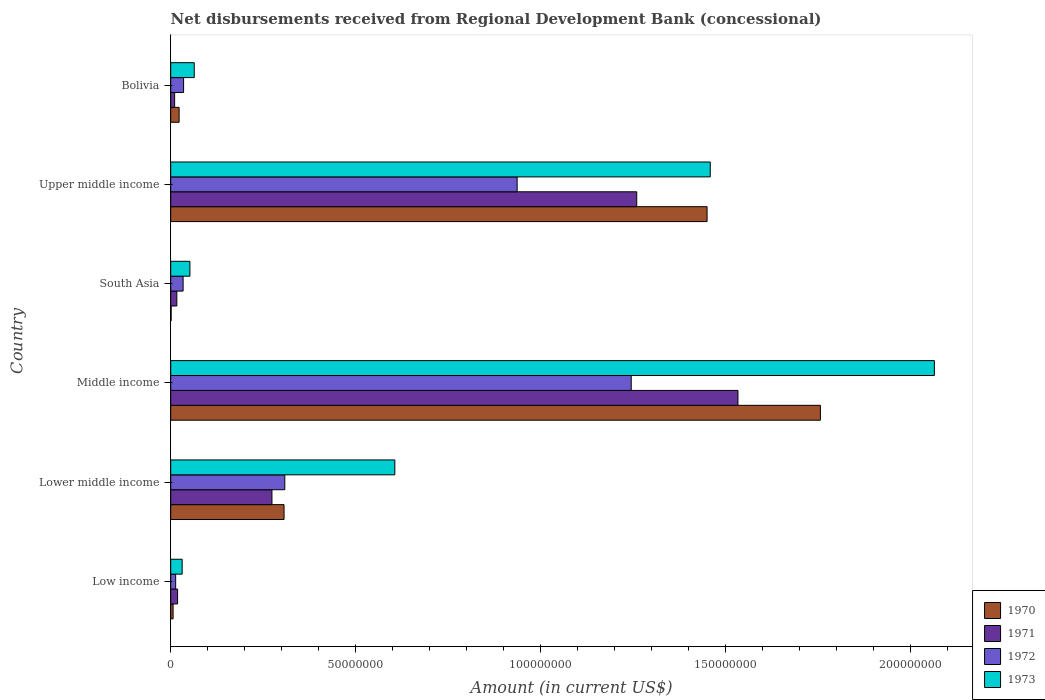How many groups of bars are there?
Provide a succinct answer. 6. How many bars are there on the 6th tick from the top?
Provide a succinct answer. 4. In how many cases, is the number of bars for a given country not equal to the number of legend labels?
Keep it short and to the point. 0. What is the amount of disbursements received from Regional Development Bank in 1970 in Lower middle income?
Your response must be concise. 3.06e+07. Across all countries, what is the maximum amount of disbursements received from Regional Development Bank in 1971?
Provide a short and direct response. 1.53e+08. Across all countries, what is the minimum amount of disbursements received from Regional Development Bank in 1973?
Give a very brief answer. 3.09e+06. In which country was the amount of disbursements received from Regional Development Bank in 1970 minimum?
Make the answer very short. South Asia. What is the total amount of disbursements received from Regional Development Bank in 1973 in the graph?
Provide a succinct answer. 4.27e+08. What is the difference between the amount of disbursements received from Regional Development Bank in 1972 in Low income and that in South Asia?
Make the answer very short. -2.02e+06. What is the difference between the amount of disbursements received from Regional Development Bank in 1972 in Bolivia and the amount of disbursements received from Regional Development Bank in 1970 in Middle income?
Give a very brief answer. -1.72e+08. What is the average amount of disbursements received from Regional Development Bank in 1971 per country?
Provide a succinct answer. 5.19e+07. What is the difference between the amount of disbursements received from Regional Development Bank in 1971 and amount of disbursements received from Regional Development Bank in 1972 in Low income?
Provide a short and direct response. 5.26e+05. What is the ratio of the amount of disbursements received from Regional Development Bank in 1970 in Low income to that in South Asia?
Provide a succinct answer. 5.94. Is the amount of disbursements received from Regional Development Bank in 1971 in Bolivia less than that in Upper middle income?
Your answer should be very brief. Yes. Is the difference between the amount of disbursements received from Regional Development Bank in 1971 in Bolivia and Middle income greater than the difference between the amount of disbursements received from Regional Development Bank in 1972 in Bolivia and Middle income?
Offer a terse response. No. What is the difference between the highest and the second highest amount of disbursements received from Regional Development Bank in 1970?
Offer a very short reply. 3.06e+07. What is the difference between the highest and the lowest amount of disbursements received from Regional Development Bank in 1970?
Your response must be concise. 1.75e+08. In how many countries, is the amount of disbursements received from Regional Development Bank in 1971 greater than the average amount of disbursements received from Regional Development Bank in 1971 taken over all countries?
Offer a very short reply. 2. Is the sum of the amount of disbursements received from Regional Development Bank in 1973 in Bolivia and Low income greater than the maximum amount of disbursements received from Regional Development Bank in 1970 across all countries?
Make the answer very short. No. Is it the case that in every country, the sum of the amount of disbursements received from Regional Development Bank in 1973 and amount of disbursements received from Regional Development Bank in 1972 is greater than the sum of amount of disbursements received from Regional Development Bank in 1971 and amount of disbursements received from Regional Development Bank in 1970?
Offer a terse response. No. What does the 4th bar from the top in South Asia represents?
Offer a terse response. 1970. What does the 1st bar from the bottom in Low income represents?
Your answer should be very brief. 1970. Is it the case that in every country, the sum of the amount of disbursements received from Regional Development Bank in 1970 and amount of disbursements received from Regional Development Bank in 1971 is greater than the amount of disbursements received from Regional Development Bank in 1972?
Your answer should be compact. No. How many bars are there?
Make the answer very short. 24. Are all the bars in the graph horizontal?
Offer a very short reply. Yes. What is the difference between two consecutive major ticks on the X-axis?
Keep it short and to the point. 5.00e+07. Does the graph contain any zero values?
Offer a very short reply. No. Does the graph contain grids?
Keep it short and to the point. No. What is the title of the graph?
Your answer should be compact. Net disbursements received from Regional Development Bank (concessional). Does "1984" appear as one of the legend labels in the graph?
Offer a very short reply. No. What is the label or title of the X-axis?
Provide a short and direct response. Amount (in current US$). What is the Amount (in current US$) of 1970 in Low income?
Keep it short and to the point. 6.47e+05. What is the Amount (in current US$) in 1971 in Low income?
Make the answer very short. 1.86e+06. What is the Amount (in current US$) of 1972 in Low income?
Keep it short and to the point. 1.33e+06. What is the Amount (in current US$) in 1973 in Low income?
Offer a very short reply. 3.09e+06. What is the Amount (in current US$) in 1970 in Lower middle income?
Offer a very short reply. 3.06e+07. What is the Amount (in current US$) in 1971 in Lower middle income?
Offer a terse response. 2.74e+07. What is the Amount (in current US$) of 1972 in Lower middle income?
Provide a succinct answer. 3.08e+07. What is the Amount (in current US$) in 1973 in Lower middle income?
Your response must be concise. 6.06e+07. What is the Amount (in current US$) in 1970 in Middle income?
Offer a very short reply. 1.76e+08. What is the Amount (in current US$) in 1971 in Middle income?
Your response must be concise. 1.53e+08. What is the Amount (in current US$) in 1972 in Middle income?
Your answer should be compact. 1.24e+08. What is the Amount (in current US$) in 1973 in Middle income?
Keep it short and to the point. 2.06e+08. What is the Amount (in current US$) in 1970 in South Asia?
Your answer should be very brief. 1.09e+05. What is the Amount (in current US$) in 1971 in South Asia?
Keep it short and to the point. 1.65e+06. What is the Amount (in current US$) in 1972 in South Asia?
Offer a very short reply. 3.35e+06. What is the Amount (in current US$) in 1973 in South Asia?
Your answer should be compact. 5.18e+06. What is the Amount (in current US$) in 1970 in Upper middle income?
Ensure brevity in your answer.  1.45e+08. What is the Amount (in current US$) of 1971 in Upper middle income?
Make the answer very short. 1.26e+08. What is the Amount (in current US$) in 1972 in Upper middle income?
Give a very brief answer. 9.36e+07. What is the Amount (in current US$) in 1973 in Upper middle income?
Keep it short and to the point. 1.46e+08. What is the Amount (in current US$) in 1970 in Bolivia?
Make the answer very short. 2.27e+06. What is the Amount (in current US$) of 1971 in Bolivia?
Make the answer very short. 1.06e+06. What is the Amount (in current US$) in 1972 in Bolivia?
Your response must be concise. 3.48e+06. What is the Amount (in current US$) of 1973 in Bolivia?
Provide a succinct answer. 6.36e+06. Across all countries, what is the maximum Amount (in current US$) of 1970?
Your response must be concise. 1.76e+08. Across all countries, what is the maximum Amount (in current US$) of 1971?
Your answer should be very brief. 1.53e+08. Across all countries, what is the maximum Amount (in current US$) in 1972?
Your answer should be very brief. 1.24e+08. Across all countries, what is the maximum Amount (in current US$) in 1973?
Keep it short and to the point. 2.06e+08. Across all countries, what is the minimum Amount (in current US$) of 1970?
Offer a terse response. 1.09e+05. Across all countries, what is the minimum Amount (in current US$) of 1971?
Offer a very short reply. 1.06e+06. Across all countries, what is the minimum Amount (in current US$) in 1972?
Provide a short and direct response. 1.33e+06. Across all countries, what is the minimum Amount (in current US$) of 1973?
Your answer should be compact. 3.09e+06. What is the total Amount (in current US$) in 1970 in the graph?
Provide a short and direct response. 3.54e+08. What is the total Amount (in current US$) of 1971 in the graph?
Ensure brevity in your answer.  3.11e+08. What is the total Amount (in current US$) of 1972 in the graph?
Provide a short and direct response. 2.57e+08. What is the total Amount (in current US$) in 1973 in the graph?
Your answer should be very brief. 4.27e+08. What is the difference between the Amount (in current US$) of 1970 in Low income and that in Lower middle income?
Offer a very short reply. -3.00e+07. What is the difference between the Amount (in current US$) of 1971 in Low income and that in Lower middle income?
Offer a terse response. -2.55e+07. What is the difference between the Amount (in current US$) of 1972 in Low income and that in Lower middle income?
Provide a succinct answer. -2.95e+07. What is the difference between the Amount (in current US$) in 1973 in Low income and that in Lower middle income?
Provide a short and direct response. -5.75e+07. What is the difference between the Amount (in current US$) of 1970 in Low income and that in Middle income?
Offer a terse response. -1.75e+08. What is the difference between the Amount (in current US$) of 1971 in Low income and that in Middle income?
Keep it short and to the point. -1.51e+08. What is the difference between the Amount (in current US$) of 1972 in Low income and that in Middle income?
Your response must be concise. -1.23e+08. What is the difference between the Amount (in current US$) of 1973 in Low income and that in Middle income?
Give a very brief answer. -2.03e+08. What is the difference between the Amount (in current US$) in 1970 in Low income and that in South Asia?
Your response must be concise. 5.38e+05. What is the difference between the Amount (in current US$) in 1971 in Low income and that in South Asia?
Your answer should be very brief. 2.09e+05. What is the difference between the Amount (in current US$) in 1972 in Low income and that in South Asia?
Your answer should be compact. -2.02e+06. What is the difference between the Amount (in current US$) of 1973 in Low income and that in South Asia?
Provide a short and direct response. -2.09e+06. What is the difference between the Amount (in current US$) of 1970 in Low income and that in Upper middle income?
Give a very brief answer. -1.44e+08. What is the difference between the Amount (in current US$) in 1971 in Low income and that in Upper middle income?
Provide a short and direct response. -1.24e+08. What is the difference between the Amount (in current US$) of 1972 in Low income and that in Upper middle income?
Offer a terse response. -9.23e+07. What is the difference between the Amount (in current US$) in 1973 in Low income and that in Upper middle income?
Give a very brief answer. -1.43e+08. What is the difference between the Amount (in current US$) in 1970 in Low income and that in Bolivia?
Your answer should be compact. -1.62e+06. What is the difference between the Amount (in current US$) of 1971 in Low income and that in Bolivia?
Your answer should be very brief. 8.01e+05. What is the difference between the Amount (in current US$) of 1972 in Low income and that in Bolivia?
Provide a succinct answer. -2.15e+06. What is the difference between the Amount (in current US$) of 1973 in Low income and that in Bolivia?
Your answer should be compact. -3.27e+06. What is the difference between the Amount (in current US$) in 1970 in Lower middle income and that in Middle income?
Your answer should be compact. -1.45e+08. What is the difference between the Amount (in current US$) of 1971 in Lower middle income and that in Middle income?
Keep it short and to the point. -1.26e+08. What is the difference between the Amount (in current US$) of 1972 in Lower middle income and that in Middle income?
Ensure brevity in your answer.  -9.36e+07. What is the difference between the Amount (in current US$) in 1973 in Lower middle income and that in Middle income?
Your answer should be compact. -1.46e+08. What is the difference between the Amount (in current US$) of 1970 in Lower middle income and that in South Asia?
Offer a very short reply. 3.05e+07. What is the difference between the Amount (in current US$) in 1971 in Lower middle income and that in South Asia?
Give a very brief answer. 2.57e+07. What is the difference between the Amount (in current US$) in 1972 in Lower middle income and that in South Asia?
Your answer should be compact. 2.75e+07. What is the difference between the Amount (in current US$) of 1973 in Lower middle income and that in South Asia?
Offer a very short reply. 5.54e+07. What is the difference between the Amount (in current US$) of 1970 in Lower middle income and that in Upper middle income?
Give a very brief answer. -1.14e+08. What is the difference between the Amount (in current US$) of 1971 in Lower middle income and that in Upper middle income?
Ensure brevity in your answer.  -9.86e+07. What is the difference between the Amount (in current US$) in 1972 in Lower middle income and that in Upper middle income?
Keep it short and to the point. -6.28e+07. What is the difference between the Amount (in current US$) in 1973 in Lower middle income and that in Upper middle income?
Provide a succinct answer. -8.52e+07. What is the difference between the Amount (in current US$) in 1970 in Lower middle income and that in Bolivia?
Ensure brevity in your answer.  2.84e+07. What is the difference between the Amount (in current US$) of 1971 in Lower middle income and that in Bolivia?
Your answer should be very brief. 2.63e+07. What is the difference between the Amount (in current US$) in 1972 in Lower middle income and that in Bolivia?
Provide a succinct answer. 2.73e+07. What is the difference between the Amount (in current US$) in 1973 in Lower middle income and that in Bolivia?
Offer a very short reply. 5.42e+07. What is the difference between the Amount (in current US$) of 1970 in Middle income and that in South Asia?
Give a very brief answer. 1.75e+08. What is the difference between the Amount (in current US$) of 1971 in Middle income and that in South Asia?
Your answer should be compact. 1.52e+08. What is the difference between the Amount (in current US$) of 1972 in Middle income and that in South Asia?
Offer a very short reply. 1.21e+08. What is the difference between the Amount (in current US$) of 1973 in Middle income and that in South Asia?
Your response must be concise. 2.01e+08. What is the difference between the Amount (in current US$) in 1970 in Middle income and that in Upper middle income?
Offer a terse response. 3.06e+07. What is the difference between the Amount (in current US$) in 1971 in Middle income and that in Upper middle income?
Make the answer very short. 2.74e+07. What is the difference between the Amount (in current US$) of 1972 in Middle income and that in Upper middle income?
Your response must be concise. 3.08e+07. What is the difference between the Amount (in current US$) of 1973 in Middle income and that in Upper middle income?
Your response must be concise. 6.06e+07. What is the difference between the Amount (in current US$) in 1970 in Middle income and that in Bolivia?
Your answer should be very brief. 1.73e+08. What is the difference between the Amount (in current US$) in 1971 in Middle income and that in Bolivia?
Make the answer very short. 1.52e+08. What is the difference between the Amount (in current US$) in 1972 in Middle income and that in Bolivia?
Offer a terse response. 1.21e+08. What is the difference between the Amount (in current US$) in 1973 in Middle income and that in Bolivia?
Keep it short and to the point. 2.00e+08. What is the difference between the Amount (in current US$) in 1970 in South Asia and that in Upper middle income?
Offer a terse response. -1.45e+08. What is the difference between the Amount (in current US$) in 1971 in South Asia and that in Upper middle income?
Provide a short and direct response. -1.24e+08. What is the difference between the Amount (in current US$) in 1972 in South Asia and that in Upper middle income?
Make the answer very short. -9.03e+07. What is the difference between the Amount (in current US$) in 1973 in South Asia and that in Upper middle income?
Make the answer very short. -1.41e+08. What is the difference between the Amount (in current US$) of 1970 in South Asia and that in Bolivia?
Make the answer very short. -2.16e+06. What is the difference between the Amount (in current US$) in 1971 in South Asia and that in Bolivia?
Your answer should be compact. 5.92e+05. What is the difference between the Amount (in current US$) in 1972 in South Asia and that in Bolivia?
Make the answer very short. -1.30e+05. What is the difference between the Amount (in current US$) in 1973 in South Asia and that in Bolivia?
Offer a terse response. -1.18e+06. What is the difference between the Amount (in current US$) of 1970 in Upper middle income and that in Bolivia?
Your response must be concise. 1.43e+08. What is the difference between the Amount (in current US$) in 1971 in Upper middle income and that in Bolivia?
Your answer should be very brief. 1.25e+08. What is the difference between the Amount (in current US$) in 1972 in Upper middle income and that in Bolivia?
Keep it short and to the point. 9.01e+07. What is the difference between the Amount (in current US$) in 1973 in Upper middle income and that in Bolivia?
Offer a terse response. 1.39e+08. What is the difference between the Amount (in current US$) in 1970 in Low income and the Amount (in current US$) in 1971 in Lower middle income?
Offer a terse response. -2.67e+07. What is the difference between the Amount (in current US$) in 1970 in Low income and the Amount (in current US$) in 1972 in Lower middle income?
Ensure brevity in your answer.  -3.02e+07. What is the difference between the Amount (in current US$) of 1970 in Low income and the Amount (in current US$) of 1973 in Lower middle income?
Give a very brief answer. -5.99e+07. What is the difference between the Amount (in current US$) in 1971 in Low income and the Amount (in current US$) in 1972 in Lower middle income?
Your answer should be compact. -2.90e+07. What is the difference between the Amount (in current US$) in 1971 in Low income and the Amount (in current US$) in 1973 in Lower middle income?
Your answer should be very brief. -5.87e+07. What is the difference between the Amount (in current US$) in 1972 in Low income and the Amount (in current US$) in 1973 in Lower middle income?
Give a very brief answer. -5.92e+07. What is the difference between the Amount (in current US$) of 1970 in Low income and the Amount (in current US$) of 1971 in Middle income?
Give a very brief answer. -1.53e+08. What is the difference between the Amount (in current US$) in 1970 in Low income and the Amount (in current US$) in 1972 in Middle income?
Give a very brief answer. -1.24e+08. What is the difference between the Amount (in current US$) in 1970 in Low income and the Amount (in current US$) in 1973 in Middle income?
Your answer should be compact. -2.06e+08. What is the difference between the Amount (in current US$) in 1971 in Low income and the Amount (in current US$) in 1972 in Middle income?
Your answer should be compact. -1.23e+08. What is the difference between the Amount (in current US$) in 1971 in Low income and the Amount (in current US$) in 1973 in Middle income?
Provide a succinct answer. -2.04e+08. What is the difference between the Amount (in current US$) in 1972 in Low income and the Amount (in current US$) in 1973 in Middle income?
Ensure brevity in your answer.  -2.05e+08. What is the difference between the Amount (in current US$) of 1970 in Low income and the Amount (in current US$) of 1971 in South Asia?
Provide a short and direct response. -1.00e+06. What is the difference between the Amount (in current US$) in 1970 in Low income and the Amount (in current US$) in 1972 in South Asia?
Keep it short and to the point. -2.70e+06. What is the difference between the Amount (in current US$) in 1970 in Low income and the Amount (in current US$) in 1973 in South Asia?
Your response must be concise. -4.54e+06. What is the difference between the Amount (in current US$) in 1971 in Low income and the Amount (in current US$) in 1972 in South Asia?
Offer a terse response. -1.49e+06. What is the difference between the Amount (in current US$) of 1971 in Low income and the Amount (in current US$) of 1973 in South Asia?
Your answer should be compact. -3.32e+06. What is the difference between the Amount (in current US$) in 1972 in Low income and the Amount (in current US$) in 1973 in South Asia?
Provide a succinct answer. -3.85e+06. What is the difference between the Amount (in current US$) of 1970 in Low income and the Amount (in current US$) of 1971 in Upper middle income?
Keep it short and to the point. -1.25e+08. What is the difference between the Amount (in current US$) of 1970 in Low income and the Amount (in current US$) of 1972 in Upper middle income?
Keep it short and to the point. -9.30e+07. What is the difference between the Amount (in current US$) in 1970 in Low income and the Amount (in current US$) in 1973 in Upper middle income?
Offer a terse response. -1.45e+08. What is the difference between the Amount (in current US$) of 1971 in Low income and the Amount (in current US$) of 1972 in Upper middle income?
Keep it short and to the point. -9.17e+07. What is the difference between the Amount (in current US$) of 1971 in Low income and the Amount (in current US$) of 1973 in Upper middle income?
Keep it short and to the point. -1.44e+08. What is the difference between the Amount (in current US$) in 1972 in Low income and the Amount (in current US$) in 1973 in Upper middle income?
Your answer should be very brief. -1.44e+08. What is the difference between the Amount (in current US$) in 1970 in Low income and the Amount (in current US$) in 1971 in Bolivia?
Offer a terse response. -4.11e+05. What is the difference between the Amount (in current US$) of 1970 in Low income and the Amount (in current US$) of 1972 in Bolivia?
Offer a terse response. -2.83e+06. What is the difference between the Amount (in current US$) in 1970 in Low income and the Amount (in current US$) in 1973 in Bolivia?
Provide a short and direct response. -5.71e+06. What is the difference between the Amount (in current US$) of 1971 in Low income and the Amount (in current US$) of 1972 in Bolivia?
Provide a succinct answer. -1.62e+06. What is the difference between the Amount (in current US$) of 1971 in Low income and the Amount (in current US$) of 1973 in Bolivia?
Your response must be concise. -4.50e+06. What is the difference between the Amount (in current US$) of 1972 in Low income and the Amount (in current US$) of 1973 in Bolivia?
Your response must be concise. -5.03e+06. What is the difference between the Amount (in current US$) in 1970 in Lower middle income and the Amount (in current US$) in 1971 in Middle income?
Offer a very short reply. -1.23e+08. What is the difference between the Amount (in current US$) of 1970 in Lower middle income and the Amount (in current US$) of 1972 in Middle income?
Your answer should be very brief. -9.38e+07. What is the difference between the Amount (in current US$) of 1970 in Lower middle income and the Amount (in current US$) of 1973 in Middle income?
Give a very brief answer. -1.76e+08. What is the difference between the Amount (in current US$) of 1971 in Lower middle income and the Amount (in current US$) of 1972 in Middle income?
Offer a terse response. -9.71e+07. What is the difference between the Amount (in current US$) in 1971 in Lower middle income and the Amount (in current US$) in 1973 in Middle income?
Provide a succinct answer. -1.79e+08. What is the difference between the Amount (in current US$) in 1972 in Lower middle income and the Amount (in current US$) in 1973 in Middle income?
Make the answer very short. -1.76e+08. What is the difference between the Amount (in current US$) of 1970 in Lower middle income and the Amount (in current US$) of 1971 in South Asia?
Offer a terse response. 2.90e+07. What is the difference between the Amount (in current US$) of 1970 in Lower middle income and the Amount (in current US$) of 1972 in South Asia?
Offer a terse response. 2.73e+07. What is the difference between the Amount (in current US$) of 1970 in Lower middle income and the Amount (in current US$) of 1973 in South Asia?
Make the answer very short. 2.54e+07. What is the difference between the Amount (in current US$) of 1971 in Lower middle income and the Amount (in current US$) of 1972 in South Asia?
Keep it short and to the point. 2.40e+07. What is the difference between the Amount (in current US$) of 1971 in Lower middle income and the Amount (in current US$) of 1973 in South Asia?
Make the answer very short. 2.22e+07. What is the difference between the Amount (in current US$) in 1972 in Lower middle income and the Amount (in current US$) in 1973 in South Asia?
Give a very brief answer. 2.56e+07. What is the difference between the Amount (in current US$) in 1970 in Lower middle income and the Amount (in current US$) in 1971 in Upper middle income?
Give a very brief answer. -9.53e+07. What is the difference between the Amount (in current US$) of 1970 in Lower middle income and the Amount (in current US$) of 1972 in Upper middle income?
Give a very brief answer. -6.30e+07. What is the difference between the Amount (in current US$) in 1970 in Lower middle income and the Amount (in current US$) in 1973 in Upper middle income?
Your response must be concise. -1.15e+08. What is the difference between the Amount (in current US$) in 1971 in Lower middle income and the Amount (in current US$) in 1972 in Upper middle income?
Make the answer very short. -6.63e+07. What is the difference between the Amount (in current US$) of 1971 in Lower middle income and the Amount (in current US$) of 1973 in Upper middle income?
Provide a short and direct response. -1.18e+08. What is the difference between the Amount (in current US$) in 1972 in Lower middle income and the Amount (in current US$) in 1973 in Upper middle income?
Your answer should be compact. -1.15e+08. What is the difference between the Amount (in current US$) in 1970 in Lower middle income and the Amount (in current US$) in 1971 in Bolivia?
Provide a short and direct response. 2.96e+07. What is the difference between the Amount (in current US$) in 1970 in Lower middle income and the Amount (in current US$) in 1972 in Bolivia?
Make the answer very short. 2.71e+07. What is the difference between the Amount (in current US$) in 1970 in Lower middle income and the Amount (in current US$) in 1973 in Bolivia?
Keep it short and to the point. 2.43e+07. What is the difference between the Amount (in current US$) of 1971 in Lower middle income and the Amount (in current US$) of 1972 in Bolivia?
Make the answer very short. 2.39e+07. What is the difference between the Amount (in current US$) in 1971 in Lower middle income and the Amount (in current US$) in 1973 in Bolivia?
Your response must be concise. 2.10e+07. What is the difference between the Amount (in current US$) in 1972 in Lower middle income and the Amount (in current US$) in 1973 in Bolivia?
Your response must be concise. 2.45e+07. What is the difference between the Amount (in current US$) of 1970 in Middle income and the Amount (in current US$) of 1971 in South Asia?
Provide a succinct answer. 1.74e+08. What is the difference between the Amount (in current US$) in 1970 in Middle income and the Amount (in current US$) in 1972 in South Asia?
Your answer should be compact. 1.72e+08. What is the difference between the Amount (in current US$) of 1970 in Middle income and the Amount (in current US$) of 1973 in South Asia?
Keep it short and to the point. 1.70e+08. What is the difference between the Amount (in current US$) in 1971 in Middle income and the Amount (in current US$) in 1972 in South Asia?
Your answer should be very brief. 1.50e+08. What is the difference between the Amount (in current US$) of 1971 in Middle income and the Amount (in current US$) of 1973 in South Asia?
Provide a short and direct response. 1.48e+08. What is the difference between the Amount (in current US$) of 1972 in Middle income and the Amount (in current US$) of 1973 in South Asia?
Offer a very short reply. 1.19e+08. What is the difference between the Amount (in current US$) of 1970 in Middle income and the Amount (in current US$) of 1971 in Upper middle income?
Your answer should be very brief. 4.96e+07. What is the difference between the Amount (in current US$) of 1970 in Middle income and the Amount (in current US$) of 1972 in Upper middle income?
Your response must be concise. 8.19e+07. What is the difference between the Amount (in current US$) in 1970 in Middle income and the Amount (in current US$) in 1973 in Upper middle income?
Provide a succinct answer. 2.98e+07. What is the difference between the Amount (in current US$) in 1971 in Middle income and the Amount (in current US$) in 1972 in Upper middle income?
Your answer should be very brief. 5.97e+07. What is the difference between the Amount (in current US$) in 1971 in Middle income and the Amount (in current US$) in 1973 in Upper middle income?
Ensure brevity in your answer.  7.49e+06. What is the difference between the Amount (in current US$) in 1972 in Middle income and the Amount (in current US$) in 1973 in Upper middle income?
Your answer should be compact. -2.14e+07. What is the difference between the Amount (in current US$) of 1970 in Middle income and the Amount (in current US$) of 1971 in Bolivia?
Ensure brevity in your answer.  1.74e+08. What is the difference between the Amount (in current US$) of 1970 in Middle income and the Amount (in current US$) of 1972 in Bolivia?
Offer a terse response. 1.72e+08. What is the difference between the Amount (in current US$) in 1970 in Middle income and the Amount (in current US$) in 1973 in Bolivia?
Ensure brevity in your answer.  1.69e+08. What is the difference between the Amount (in current US$) of 1971 in Middle income and the Amount (in current US$) of 1972 in Bolivia?
Your response must be concise. 1.50e+08. What is the difference between the Amount (in current US$) of 1971 in Middle income and the Amount (in current US$) of 1973 in Bolivia?
Ensure brevity in your answer.  1.47e+08. What is the difference between the Amount (in current US$) of 1972 in Middle income and the Amount (in current US$) of 1973 in Bolivia?
Your answer should be very brief. 1.18e+08. What is the difference between the Amount (in current US$) in 1970 in South Asia and the Amount (in current US$) in 1971 in Upper middle income?
Give a very brief answer. -1.26e+08. What is the difference between the Amount (in current US$) in 1970 in South Asia and the Amount (in current US$) in 1972 in Upper middle income?
Ensure brevity in your answer.  -9.35e+07. What is the difference between the Amount (in current US$) in 1970 in South Asia and the Amount (in current US$) in 1973 in Upper middle income?
Give a very brief answer. -1.46e+08. What is the difference between the Amount (in current US$) of 1971 in South Asia and the Amount (in current US$) of 1972 in Upper middle income?
Your response must be concise. -9.20e+07. What is the difference between the Amount (in current US$) in 1971 in South Asia and the Amount (in current US$) in 1973 in Upper middle income?
Provide a short and direct response. -1.44e+08. What is the difference between the Amount (in current US$) of 1972 in South Asia and the Amount (in current US$) of 1973 in Upper middle income?
Ensure brevity in your answer.  -1.42e+08. What is the difference between the Amount (in current US$) in 1970 in South Asia and the Amount (in current US$) in 1971 in Bolivia?
Provide a succinct answer. -9.49e+05. What is the difference between the Amount (in current US$) of 1970 in South Asia and the Amount (in current US$) of 1972 in Bolivia?
Your answer should be very brief. -3.37e+06. What is the difference between the Amount (in current US$) in 1970 in South Asia and the Amount (in current US$) in 1973 in Bolivia?
Ensure brevity in your answer.  -6.25e+06. What is the difference between the Amount (in current US$) of 1971 in South Asia and the Amount (in current US$) of 1972 in Bolivia?
Your response must be concise. -1.83e+06. What is the difference between the Amount (in current US$) of 1971 in South Asia and the Amount (in current US$) of 1973 in Bolivia?
Offer a very short reply. -4.71e+06. What is the difference between the Amount (in current US$) in 1972 in South Asia and the Amount (in current US$) in 1973 in Bolivia?
Make the answer very short. -3.01e+06. What is the difference between the Amount (in current US$) of 1970 in Upper middle income and the Amount (in current US$) of 1971 in Bolivia?
Offer a terse response. 1.44e+08. What is the difference between the Amount (in current US$) in 1970 in Upper middle income and the Amount (in current US$) in 1972 in Bolivia?
Provide a short and direct response. 1.41e+08. What is the difference between the Amount (in current US$) of 1970 in Upper middle income and the Amount (in current US$) of 1973 in Bolivia?
Ensure brevity in your answer.  1.39e+08. What is the difference between the Amount (in current US$) in 1971 in Upper middle income and the Amount (in current US$) in 1972 in Bolivia?
Your answer should be very brief. 1.22e+08. What is the difference between the Amount (in current US$) in 1971 in Upper middle income and the Amount (in current US$) in 1973 in Bolivia?
Your response must be concise. 1.20e+08. What is the difference between the Amount (in current US$) in 1972 in Upper middle income and the Amount (in current US$) in 1973 in Bolivia?
Keep it short and to the point. 8.72e+07. What is the average Amount (in current US$) of 1970 per country?
Provide a succinct answer. 5.90e+07. What is the average Amount (in current US$) of 1971 per country?
Your answer should be compact. 5.19e+07. What is the average Amount (in current US$) of 1972 per country?
Your answer should be very brief. 4.28e+07. What is the average Amount (in current US$) of 1973 per country?
Offer a very short reply. 7.12e+07. What is the difference between the Amount (in current US$) in 1970 and Amount (in current US$) in 1971 in Low income?
Make the answer very short. -1.21e+06. What is the difference between the Amount (in current US$) in 1970 and Amount (in current US$) in 1972 in Low income?
Offer a terse response. -6.86e+05. What is the difference between the Amount (in current US$) in 1970 and Amount (in current US$) in 1973 in Low income?
Your answer should be compact. -2.44e+06. What is the difference between the Amount (in current US$) of 1971 and Amount (in current US$) of 1972 in Low income?
Your answer should be compact. 5.26e+05. What is the difference between the Amount (in current US$) in 1971 and Amount (in current US$) in 1973 in Low income?
Keep it short and to the point. -1.23e+06. What is the difference between the Amount (in current US$) of 1972 and Amount (in current US$) of 1973 in Low income?
Make the answer very short. -1.76e+06. What is the difference between the Amount (in current US$) of 1970 and Amount (in current US$) of 1971 in Lower middle income?
Make the answer very short. 3.27e+06. What is the difference between the Amount (in current US$) in 1970 and Amount (in current US$) in 1972 in Lower middle income?
Provide a succinct answer. -2.02e+05. What is the difference between the Amount (in current US$) of 1970 and Amount (in current US$) of 1973 in Lower middle income?
Offer a very short reply. -2.99e+07. What is the difference between the Amount (in current US$) of 1971 and Amount (in current US$) of 1972 in Lower middle income?
Your response must be concise. -3.47e+06. What is the difference between the Amount (in current US$) of 1971 and Amount (in current US$) of 1973 in Lower middle income?
Make the answer very short. -3.32e+07. What is the difference between the Amount (in current US$) in 1972 and Amount (in current US$) in 1973 in Lower middle income?
Provide a succinct answer. -2.97e+07. What is the difference between the Amount (in current US$) of 1970 and Amount (in current US$) of 1971 in Middle income?
Ensure brevity in your answer.  2.23e+07. What is the difference between the Amount (in current US$) of 1970 and Amount (in current US$) of 1972 in Middle income?
Ensure brevity in your answer.  5.11e+07. What is the difference between the Amount (in current US$) in 1970 and Amount (in current US$) in 1973 in Middle income?
Ensure brevity in your answer.  -3.08e+07. What is the difference between the Amount (in current US$) in 1971 and Amount (in current US$) in 1972 in Middle income?
Make the answer very short. 2.88e+07. What is the difference between the Amount (in current US$) in 1971 and Amount (in current US$) in 1973 in Middle income?
Give a very brief answer. -5.31e+07. What is the difference between the Amount (in current US$) in 1972 and Amount (in current US$) in 1973 in Middle income?
Make the answer very short. -8.19e+07. What is the difference between the Amount (in current US$) of 1970 and Amount (in current US$) of 1971 in South Asia?
Your answer should be compact. -1.54e+06. What is the difference between the Amount (in current US$) in 1970 and Amount (in current US$) in 1972 in South Asia?
Offer a very short reply. -3.24e+06. What is the difference between the Amount (in current US$) of 1970 and Amount (in current US$) of 1973 in South Asia?
Give a very brief answer. -5.08e+06. What is the difference between the Amount (in current US$) in 1971 and Amount (in current US$) in 1972 in South Asia?
Keep it short and to the point. -1.70e+06. What is the difference between the Amount (in current US$) of 1971 and Amount (in current US$) of 1973 in South Asia?
Keep it short and to the point. -3.53e+06. What is the difference between the Amount (in current US$) of 1972 and Amount (in current US$) of 1973 in South Asia?
Offer a terse response. -1.83e+06. What is the difference between the Amount (in current US$) in 1970 and Amount (in current US$) in 1971 in Upper middle income?
Give a very brief answer. 1.90e+07. What is the difference between the Amount (in current US$) in 1970 and Amount (in current US$) in 1972 in Upper middle income?
Provide a short and direct response. 5.13e+07. What is the difference between the Amount (in current US$) in 1970 and Amount (in current US$) in 1973 in Upper middle income?
Ensure brevity in your answer.  -8.58e+05. What is the difference between the Amount (in current US$) of 1971 and Amount (in current US$) of 1972 in Upper middle income?
Keep it short and to the point. 3.23e+07. What is the difference between the Amount (in current US$) of 1971 and Amount (in current US$) of 1973 in Upper middle income?
Offer a very short reply. -1.99e+07. What is the difference between the Amount (in current US$) of 1972 and Amount (in current US$) of 1973 in Upper middle income?
Give a very brief answer. -5.22e+07. What is the difference between the Amount (in current US$) of 1970 and Amount (in current US$) of 1971 in Bolivia?
Ensure brevity in your answer.  1.21e+06. What is the difference between the Amount (in current US$) in 1970 and Amount (in current US$) in 1972 in Bolivia?
Make the answer very short. -1.21e+06. What is the difference between the Amount (in current US$) in 1970 and Amount (in current US$) in 1973 in Bolivia?
Give a very brief answer. -4.09e+06. What is the difference between the Amount (in current US$) of 1971 and Amount (in current US$) of 1972 in Bolivia?
Your answer should be compact. -2.42e+06. What is the difference between the Amount (in current US$) of 1971 and Amount (in current US$) of 1973 in Bolivia?
Give a very brief answer. -5.30e+06. What is the difference between the Amount (in current US$) of 1972 and Amount (in current US$) of 1973 in Bolivia?
Keep it short and to the point. -2.88e+06. What is the ratio of the Amount (in current US$) in 1970 in Low income to that in Lower middle income?
Ensure brevity in your answer.  0.02. What is the ratio of the Amount (in current US$) in 1971 in Low income to that in Lower middle income?
Provide a succinct answer. 0.07. What is the ratio of the Amount (in current US$) of 1972 in Low income to that in Lower middle income?
Keep it short and to the point. 0.04. What is the ratio of the Amount (in current US$) in 1973 in Low income to that in Lower middle income?
Your response must be concise. 0.05. What is the ratio of the Amount (in current US$) of 1970 in Low income to that in Middle income?
Ensure brevity in your answer.  0. What is the ratio of the Amount (in current US$) in 1971 in Low income to that in Middle income?
Provide a short and direct response. 0.01. What is the ratio of the Amount (in current US$) of 1972 in Low income to that in Middle income?
Keep it short and to the point. 0.01. What is the ratio of the Amount (in current US$) of 1973 in Low income to that in Middle income?
Make the answer very short. 0.01. What is the ratio of the Amount (in current US$) of 1970 in Low income to that in South Asia?
Your answer should be compact. 5.94. What is the ratio of the Amount (in current US$) in 1971 in Low income to that in South Asia?
Your answer should be very brief. 1.13. What is the ratio of the Amount (in current US$) in 1972 in Low income to that in South Asia?
Offer a very short reply. 0.4. What is the ratio of the Amount (in current US$) of 1973 in Low income to that in South Asia?
Your answer should be compact. 0.6. What is the ratio of the Amount (in current US$) of 1970 in Low income to that in Upper middle income?
Offer a very short reply. 0. What is the ratio of the Amount (in current US$) of 1971 in Low income to that in Upper middle income?
Your answer should be very brief. 0.01. What is the ratio of the Amount (in current US$) in 1972 in Low income to that in Upper middle income?
Make the answer very short. 0.01. What is the ratio of the Amount (in current US$) of 1973 in Low income to that in Upper middle income?
Offer a very short reply. 0.02. What is the ratio of the Amount (in current US$) of 1970 in Low income to that in Bolivia?
Keep it short and to the point. 0.28. What is the ratio of the Amount (in current US$) of 1971 in Low income to that in Bolivia?
Your answer should be very brief. 1.76. What is the ratio of the Amount (in current US$) of 1972 in Low income to that in Bolivia?
Ensure brevity in your answer.  0.38. What is the ratio of the Amount (in current US$) in 1973 in Low income to that in Bolivia?
Provide a succinct answer. 0.49. What is the ratio of the Amount (in current US$) in 1970 in Lower middle income to that in Middle income?
Provide a short and direct response. 0.17. What is the ratio of the Amount (in current US$) of 1971 in Lower middle income to that in Middle income?
Provide a short and direct response. 0.18. What is the ratio of the Amount (in current US$) of 1972 in Lower middle income to that in Middle income?
Make the answer very short. 0.25. What is the ratio of the Amount (in current US$) of 1973 in Lower middle income to that in Middle income?
Offer a very short reply. 0.29. What is the ratio of the Amount (in current US$) in 1970 in Lower middle income to that in South Asia?
Offer a very short reply. 280.94. What is the ratio of the Amount (in current US$) of 1971 in Lower middle income to that in South Asia?
Your answer should be compact. 16.58. What is the ratio of the Amount (in current US$) of 1972 in Lower middle income to that in South Asia?
Offer a terse response. 9.2. What is the ratio of the Amount (in current US$) of 1973 in Lower middle income to that in South Asia?
Provide a succinct answer. 11.68. What is the ratio of the Amount (in current US$) in 1970 in Lower middle income to that in Upper middle income?
Your response must be concise. 0.21. What is the ratio of the Amount (in current US$) in 1971 in Lower middle income to that in Upper middle income?
Your answer should be compact. 0.22. What is the ratio of the Amount (in current US$) in 1972 in Lower middle income to that in Upper middle income?
Provide a succinct answer. 0.33. What is the ratio of the Amount (in current US$) in 1973 in Lower middle income to that in Upper middle income?
Make the answer very short. 0.42. What is the ratio of the Amount (in current US$) in 1970 in Lower middle income to that in Bolivia?
Provide a short and direct response. 13.49. What is the ratio of the Amount (in current US$) of 1971 in Lower middle income to that in Bolivia?
Provide a short and direct response. 25.85. What is the ratio of the Amount (in current US$) in 1972 in Lower middle income to that in Bolivia?
Keep it short and to the point. 8.86. What is the ratio of the Amount (in current US$) of 1973 in Lower middle income to that in Bolivia?
Ensure brevity in your answer.  9.52. What is the ratio of the Amount (in current US$) in 1970 in Middle income to that in South Asia?
Your answer should be compact. 1610.58. What is the ratio of the Amount (in current US$) of 1971 in Middle income to that in South Asia?
Provide a short and direct response. 92.89. What is the ratio of the Amount (in current US$) in 1972 in Middle income to that in South Asia?
Ensure brevity in your answer.  37.14. What is the ratio of the Amount (in current US$) in 1973 in Middle income to that in South Asia?
Your answer should be compact. 39.8. What is the ratio of the Amount (in current US$) of 1970 in Middle income to that in Upper middle income?
Offer a very short reply. 1.21. What is the ratio of the Amount (in current US$) in 1971 in Middle income to that in Upper middle income?
Ensure brevity in your answer.  1.22. What is the ratio of the Amount (in current US$) of 1972 in Middle income to that in Upper middle income?
Offer a terse response. 1.33. What is the ratio of the Amount (in current US$) in 1973 in Middle income to that in Upper middle income?
Keep it short and to the point. 1.42. What is the ratio of the Amount (in current US$) in 1970 in Middle income to that in Bolivia?
Give a very brief answer. 77.34. What is the ratio of the Amount (in current US$) of 1971 in Middle income to that in Bolivia?
Your response must be concise. 144.87. What is the ratio of the Amount (in current US$) of 1972 in Middle income to that in Bolivia?
Your answer should be compact. 35.76. What is the ratio of the Amount (in current US$) in 1973 in Middle income to that in Bolivia?
Give a very brief answer. 32.44. What is the ratio of the Amount (in current US$) of 1970 in South Asia to that in Upper middle income?
Ensure brevity in your answer.  0. What is the ratio of the Amount (in current US$) in 1971 in South Asia to that in Upper middle income?
Offer a very short reply. 0.01. What is the ratio of the Amount (in current US$) in 1972 in South Asia to that in Upper middle income?
Offer a very short reply. 0.04. What is the ratio of the Amount (in current US$) of 1973 in South Asia to that in Upper middle income?
Provide a short and direct response. 0.04. What is the ratio of the Amount (in current US$) in 1970 in South Asia to that in Bolivia?
Provide a short and direct response. 0.05. What is the ratio of the Amount (in current US$) of 1971 in South Asia to that in Bolivia?
Your response must be concise. 1.56. What is the ratio of the Amount (in current US$) in 1972 in South Asia to that in Bolivia?
Make the answer very short. 0.96. What is the ratio of the Amount (in current US$) of 1973 in South Asia to that in Bolivia?
Offer a terse response. 0.82. What is the ratio of the Amount (in current US$) of 1970 in Upper middle income to that in Bolivia?
Your answer should be compact. 63.85. What is the ratio of the Amount (in current US$) of 1971 in Upper middle income to that in Bolivia?
Offer a very short reply. 119.02. What is the ratio of the Amount (in current US$) of 1972 in Upper middle income to that in Bolivia?
Provide a succinct answer. 26.9. What is the ratio of the Amount (in current US$) in 1973 in Upper middle income to that in Bolivia?
Give a very brief answer. 22.92. What is the difference between the highest and the second highest Amount (in current US$) of 1970?
Provide a short and direct response. 3.06e+07. What is the difference between the highest and the second highest Amount (in current US$) in 1971?
Provide a short and direct response. 2.74e+07. What is the difference between the highest and the second highest Amount (in current US$) in 1972?
Provide a short and direct response. 3.08e+07. What is the difference between the highest and the second highest Amount (in current US$) of 1973?
Your response must be concise. 6.06e+07. What is the difference between the highest and the lowest Amount (in current US$) of 1970?
Your answer should be compact. 1.75e+08. What is the difference between the highest and the lowest Amount (in current US$) in 1971?
Ensure brevity in your answer.  1.52e+08. What is the difference between the highest and the lowest Amount (in current US$) of 1972?
Your answer should be compact. 1.23e+08. What is the difference between the highest and the lowest Amount (in current US$) in 1973?
Ensure brevity in your answer.  2.03e+08. 